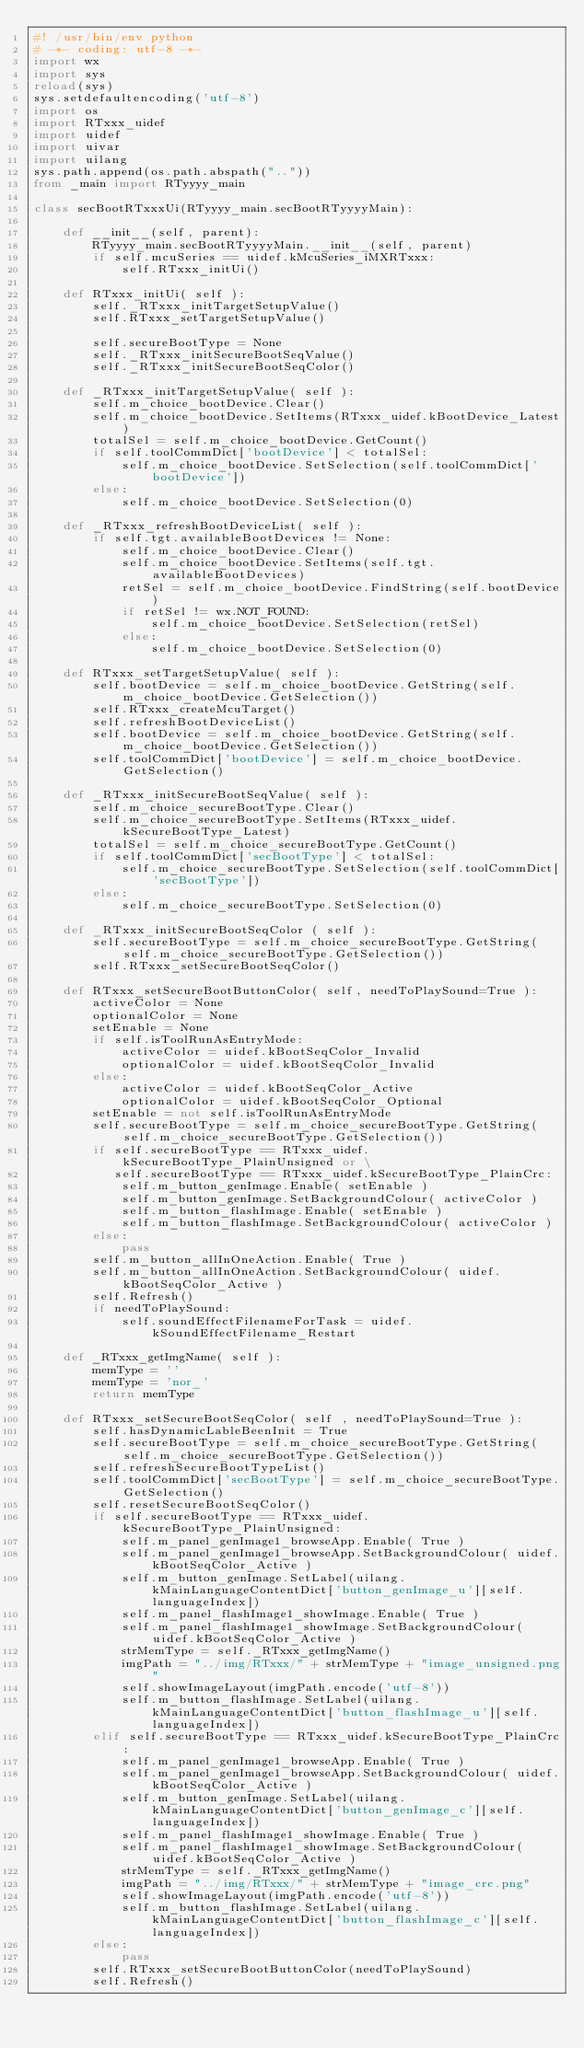<code> <loc_0><loc_0><loc_500><loc_500><_Python_>#! /usr/bin/env python
# -*- coding: utf-8 -*-
import wx
import sys
reload(sys)
sys.setdefaultencoding('utf-8')
import os
import RTxxx_uidef
import uidef
import uivar
import uilang
sys.path.append(os.path.abspath(".."))
from _main import RTyyyy_main

class secBootRTxxxUi(RTyyyy_main.secBootRTyyyyMain):

    def __init__(self, parent):
        RTyyyy_main.secBootRTyyyyMain.__init__(self, parent)
        if self.mcuSeries == uidef.kMcuSeries_iMXRTxxx:
            self.RTxxx_initUi()

    def RTxxx_initUi( self ):
        self._RTxxx_initTargetSetupValue()
        self.RTxxx_setTargetSetupValue()

        self.secureBootType = None
        self._RTxxx_initSecureBootSeqValue()
        self._RTxxx_initSecureBootSeqColor()

    def _RTxxx_initTargetSetupValue( self ):
        self.m_choice_bootDevice.Clear()
        self.m_choice_bootDevice.SetItems(RTxxx_uidef.kBootDevice_Latest)
        totalSel = self.m_choice_bootDevice.GetCount()
        if self.toolCommDict['bootDevice'] < totalSel:
            self.m_choice_bootDevice.SetSelection(self.toolCommDict['bootDevice'])
        else:
            self.m_choice_bootDevice.SetSelection(0)

    def _RTxxx_refreshBootDeviceList( self ):
        if self.tgt.availableBootDevices != None:
            self.m_choice_bootDevice.Clear()
            self.m_choice_bootDevice.SetItems(self.tgt.availableBootDevices)
            retSel = self.m_choice_bootDevice.FindString(self.bootDevice)
            if retSel != wx.NOT_FOUND:
                self.m_choice_bootDevice.SetSelection(retSel)
            else:
                self.m_choice_bootDevice.SetSelection(0)

    def RTxxx_setTargetSetupValue( self ):
        self.bootDevice = self.m_choice_bootDevice.GetString(self.m_choice_bootDevice.GetSelection())
        self.RTxxx_createMcuTarget()
        self.refreshBootDeviceList()
        self.bootDevice = self.m_choice_bootDevice.GetString(self.m_choice_bootDevice.GetSelection())
        self.toolCommDict['bootDevice'] = self.m_choice_bootDevice.GetSelection()

    def _RTxxx_initSecureBootSeqValue( self ):
        self.m_choice_secureBootType.Clear()
        self.m_choice_secureBootType.SetItems(RTxxx_uidef.kSecureBootType_Latest)
        totalSel = self.m_choice_secureBootType.GetCount()
        if self.toolCommDict['secBootType'] < totalSel:
            self.m_choice_secureBootType.SetSelection(self.toolCommDict['secBootType'])
        else:
            self.m_choice_secureBootType.SetSelection(0)

    def _RTxxx_initSecureBootSeqColor ( self ):
        self.secureBootType = self.m_choice_secureBootType.GetString(self.m_choice_secureBootType.GetSelection())
        self.RTxxx_setSecureBootSeqColor()

    def RTxxx_setSecureBootButtonColor( self, needToPlaySound=True ):
        activeColor = None
        optionalColor = None
        setEnable = None
        if self.isToolRunAsEntryMode:
            activeColor = uidef.kBootSeqColor_Invalid
            optionalColor = uidef.kBootSeqColor_Invalid
        else:
            activeColor = uidef.kBootSeqColor_Active
            optionalColor = uidef.kBootSeqColor_Optional
        setEnable = not self.isToolRunAsEntryMode
        self.secureBootType = self.m_choice_secureBootType.GetString(self.m_choice_secureBootType.GetSelection())
        if self.secureBootType == RTxxx_uidef.kSecureBootType_PlainUnsigned or \
           self.secureBootType == RTxxx_uidef.kSecureBootType_PlainCrc:
            self.m_button_genImage.Enable( setEnable )
            self.m_button_genImage.SetBackgroundColour( activeColor )
            self.m_button_flashImage.Enable( setEnable )
            self.m_button_flashImage.SetBackgroundColour( activeColor )
        else:
            pass
        self.m_button_allInOneAction.Enable( True )
        self.m_button_allInOneAction.SetBackgroundColour( uidef.kBootSeqColor_Active )
        self.Refresh()
        if needToPlaySound:
            self.soundEffectFilenameForTask = uidef.kSoundEffectFilename_Restart

    def _RTxxx_getImgName( self ):
        memType = ''
        memType = 'nor_'
        return memType

    def RTxxx_setSecureBootSeqColor( self , needToPlaySound=True ):
        self.hasDynamicLableBeenInit = True
        self.secureBootType = self.m_choice_secureBootType.GetString(self.m_choice_secureBootType.GetSelection())
        self.refreshSecureBootTypeList()
        self.toolCommDict['secBootType'] = self.m_choice_secureBootType.GetSelection()
        self.resetSecureBootSeqColor()
        if self.secureBootType == RTxxx_uidef.kSecureBootType_PlainUnsigned:
            self.m_panel_genImage1_browseApp.Enable( True )
            self.m_panel_genImage1_browseApp.SetBackgroundColour( uidef.kBootSeqColor_Active )
            self.m_button_genImage.SetLabel(uilang.kMainLanguageContentDict['button_genImage_u'][self.languageIndex])
            self.m_panel_flashImage1_showImage.Enable( True )
            self.m_panel_flashImage1_showImage.SetBackgroundColour( uidef.kBootSeqColor_Active )
            strMemType = self._RTxxx_getImgName()
            imgPath = "../img/RTxxx/" + strMemType + "image_unsigned.png"
            self.showImageLayout(imgPath.encode('utf-8'))
            self.m_button_flashImage.SetLabel(uilang.kMainLanguageContentDict['button_flashImage_u'][self.languageIndex])
        elif self.secureBootType == RTxxx_uidef.kSecureBootType_PlainCrc:
            self.m_panel_genImage1_browseApp.Enable( True )
            self.m_panel_genImage1_browseApp.SetBackgroundColour( uidef.kBootSeqColor_Active )
            self.m_button_genImage.SetLabel(uilang.kMainLanguageContentDict['button_genImage_c'][self.languageIndex])
            self.m_panel_flashImage1_showImage.Enable( True )
            self.m_panel_flashImage1_showImage.SetBackgroundColour( uidef.kBootSeqColor_Active )
            strMemType = self._RTxxx_getImgName()
            imgPath = "../img/RTxxx/" + strMemType + "image_crc.png"
            self.showImageLayout(imgPath.encode('utf-8'))
            self.m_button_flashImage.SetLabel(uilang.kMainLanguageContentDict['button_flashImage_c'][self.languageIndex])
        else:
            pass
        self.RTxxx_setSecureBootButtonColor(needToPlaySound)
        self.Refresh()
</code> 